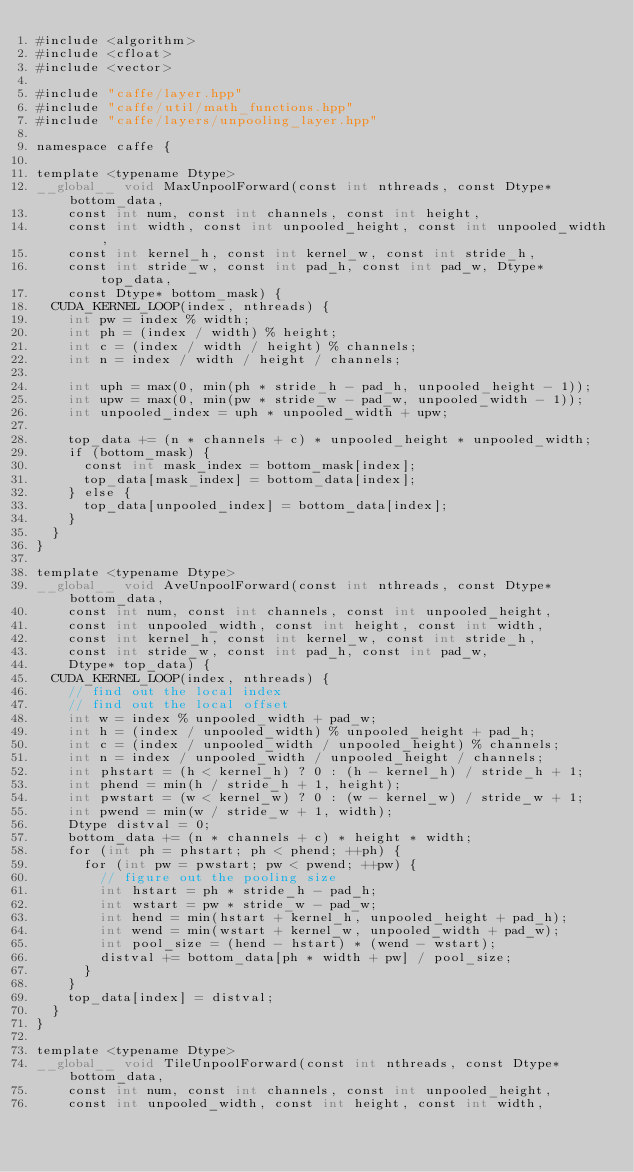<code> <loc_0><loc_0><loc_500><loc_500><_Cuda_>#include <algorithm>
#include <cfloat>
#include <vector>

#include "caffe/layer.hpp"
#include "caffe/util/math_functions.hpp"
#include "caffe/layers/unpooling_layer.hpp"

namespace caffe {

template <typename Dtype>
__global__ void MaxUnpoolForward(const int nthreads, const Dtype* bottom_data,
    const int num, const int channels, const int height,
    const int width, const int unpooled_height, const int unpooled_width,
    const int kernel_h, const int kernel_w, const int stride_h,
    const int stride_w, const int pad_h, const int pad_w, Dtype* top_data,
    const Dtype* bottom_mask) {
  CUDA_KERNEL_LOOP(index, nthreads) {
    int pw = index % width;
    int ph = (index / width) % height;
    int c = (index / width / height) % channels;
    int n = index / width / height / channels;

    int uph = max(0, min(ph * stride_h - pad_h, unpooled_height - 1));
    int upw = max(0, min(pw * stride_w - pad_w, unpooled_width - 1));
    int unpooled_index = uph * unpooled_width + upw;

    top_data += (n * channels + c) * unpooled_height * unpooled_width;
    if (bottom_mask) {
      const int mask_index = bottom_mask[index];
      top_data[mask_index] = bottom_data[index];
    } else {
      top_data[unpooled_index] = bottom_data[index];
    }
  }
}

template <typename Dtype>
__global__ void AveUnpoolForward(const int nthreads, const Dtype* bottom_data,
    const int num, const int channels, const int unpooled_height,
    const int unpooled_width, const int height, const int width,
    const int kernel_h, const int kernel_w, const int stride_h,
    const int stride_w, const int pad_h, const int pad_w,
    Dtype* top_data) {
  CUDA_KERNEL_LOOP(index, nthreads) {
    // find out the local index
    // find out the local offset
    int w = index % unpooled_width + pad_w;
    int h = (index / unpooled_width) % unpooled_height + pad_h;
    int c = (index / unpooled_width / unpooled_height) % channels;
    int n = index / unpooled_width / unpooled_height / channels;
    int phstart = (h < kernel_h) ? 0 : (h - kernel_h) / stride_h + 1;
    int phend = min(h / stride_h + 1, height);
    int pwstart = (w < kernel_w) ? 0 : (w - kernel_w) / stride_w + 1;
    int pwend = min(w / stride_w + 1, width);
    Dtype distval = 0;
    bottom_data += (n * channels + c) * height * width;
    for (int ph = phstart; ph < phend; ++ph) {
      for (int pw = pwstart; pw < pwend; ++pw) {
        // figure out the pooling size
        int hstart = ph * stride_h - pad_h;
        int wstart = pw * stride_w - pad_w;
        int hend = min(hstart + kernel_h, unpooled_height + pad_h);
        int wend = min(wstart + kernel_w, unpooled_width + pad_w);
        int pool_size = (hend - hstart) * (wend - wstart);
        distval += bottom_data[ph * width + pw] / pool_size;
      }
    }
    top_data[index] = distval;
  }
}

template <typename Dtype>
__global__ void TileUnpoolForward(const int nthreads, const Dtype* bottom_data,
    const int num, const int channels, const int unpooled_height,
    const int unpooled_width, const int height, const int width,</code> 